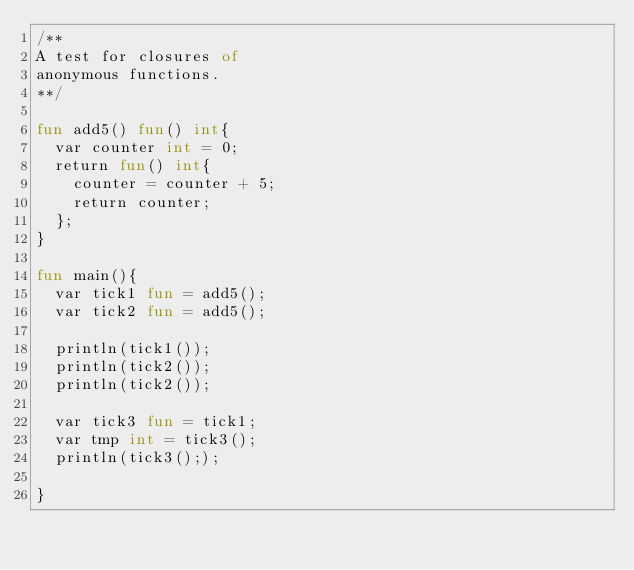<code> <loc_0><loc_0><loc_500><loc_500><_SML_>/** 
A test for closures of
anonymous functions.
**/ 

fun add5() fun() int{
	var counter int = 0;
	return fun() int{
		counter = counter + 5;
		return counter;
	};
}

fun main(){
	var tick1 fun = add5();
	var tick2 fun = add5();
	
	println(tick1());
	println(tick2());
	println(tick2());
	
	var tick3 fun = tick1;
	var tmp int = tick3();
	println(tick3(););
	
}

</code> 